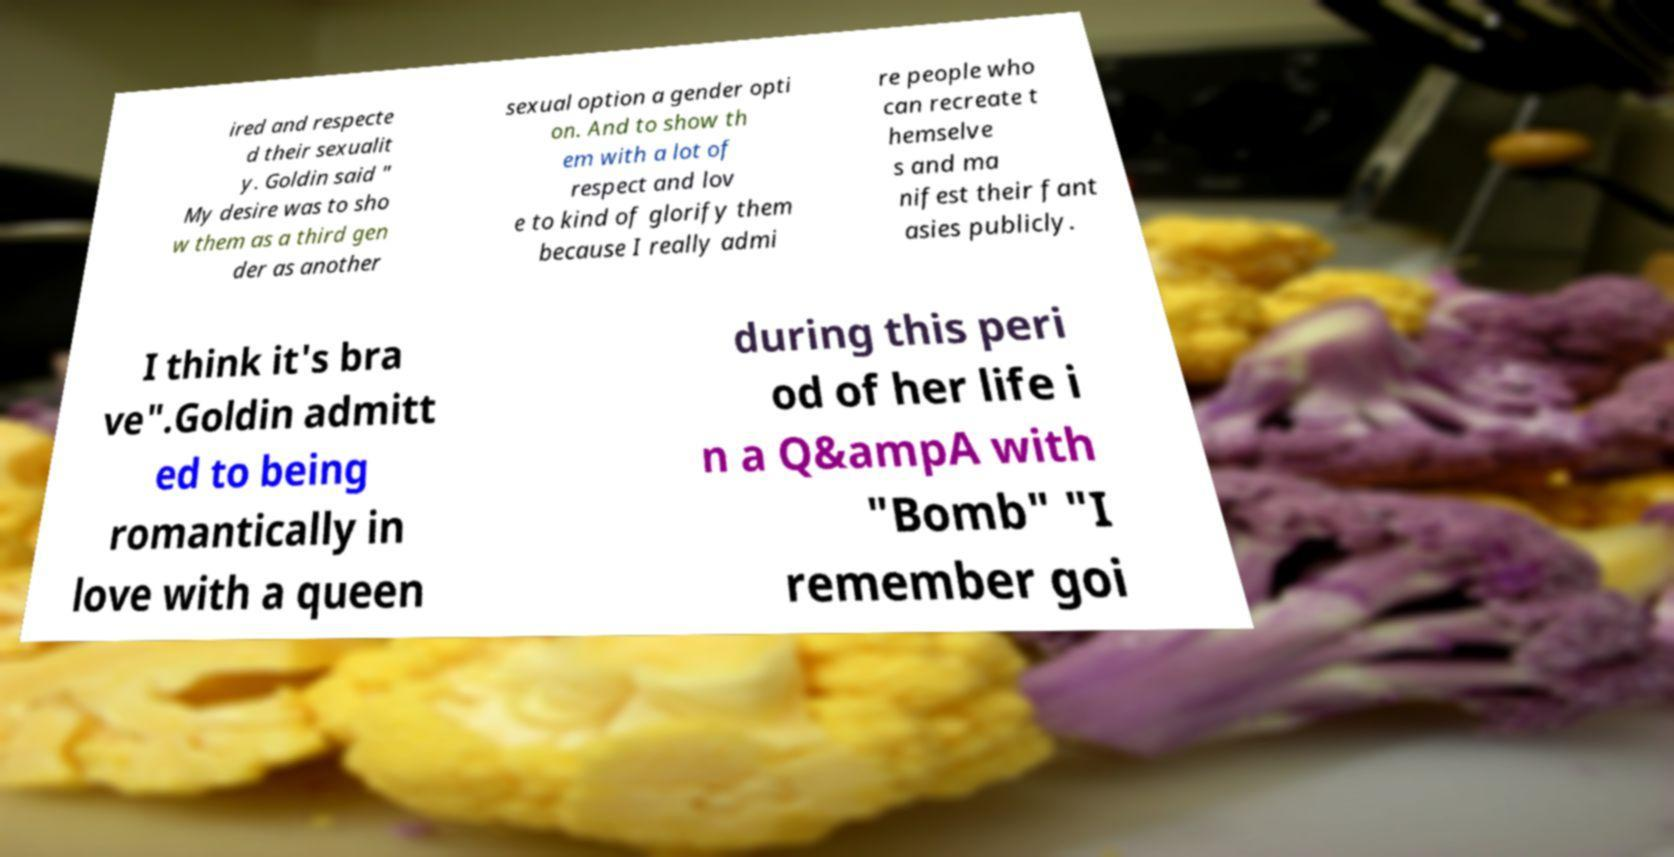I need the written content from this picture converted into text. Can you do that? ired and respecte d their sexualit y. Goldin said " My desire was to sho w them as a third gen der as another sexual option a gender opti on. And to show th em with a lot of respect and lov e to kind of glorify them because I really admi re people who can recreate t hemselve s and ma nifest their fant asies publicly. I think it's bra ve".Goldin admitt ed to being romantically in love with a queen during this peri od of her life i n a Q&ampA with "Bomb" "I remember goi 